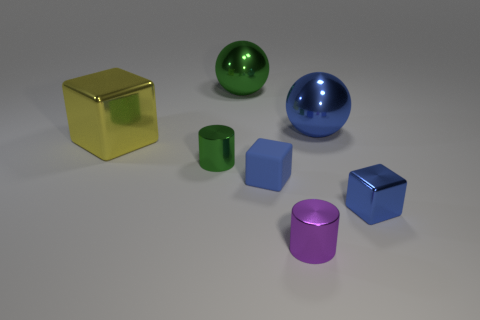Are there fewer small cylinders on the right side of the small green cylinder than purple matte cylinders? Upon inspecting the image, it appears that the number of small cylinders on the right side of the small green cylinder is exactly two, which is the same as the number of purple matte cylinders present. Therefore, the answer is no, there are not fewer small cylinders on the right side of the small green cylinder than purple matte cylinders. 